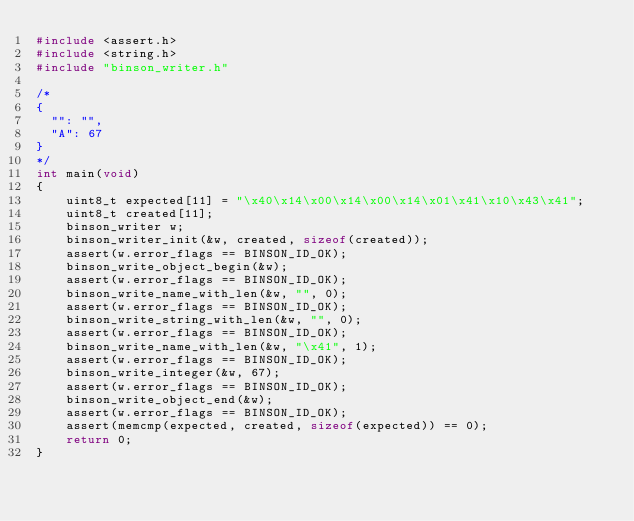Convert code to text. <code><loc_0><loc_0><loc_500><loc_500><_C_>#include <assert.h>
#include <string.h>
#include "binson_writer.h"

/*
{
  "": "", 
  "A": 67
}
*/
int main(void)
{
    uint8_t expected[11] = "\x40\x14\x00\x14\x00\x14\x01\x41\x10\x43\x41";
    uint8_t created[11];
    binson_writer w;
    binson_writer_init(&w, created, sizeof(created));
    assert(w.error_flags == BINSON_ID_OK);
    binson_write_object_begin(&w);
    assert(w.error_flags == BINSON_ID_OK);
    binson_write_name_with_len(&w, "", 0);
    assert(w.error_flags == BINSON_ID_OK);
    binson_write_string_with_len(&w, "", 0);
    assert(w.error_flags == BINSON_ID_OK);
    binson_write_name_with_len(&w, "\x41", 1);
    assert(w.error_flags == BINSON_ID_OK);
    binson_write_integer(&w, 67);
    assert(w.error_flags == BINSON_ID_OK);
    binson_write_object_end(&w);
    assert(w.error_flags == BINSON_ID_OK);
    assert(memcmp(expected, created, sizeof(expected)) == 0);
    return 0;
}

</code> 